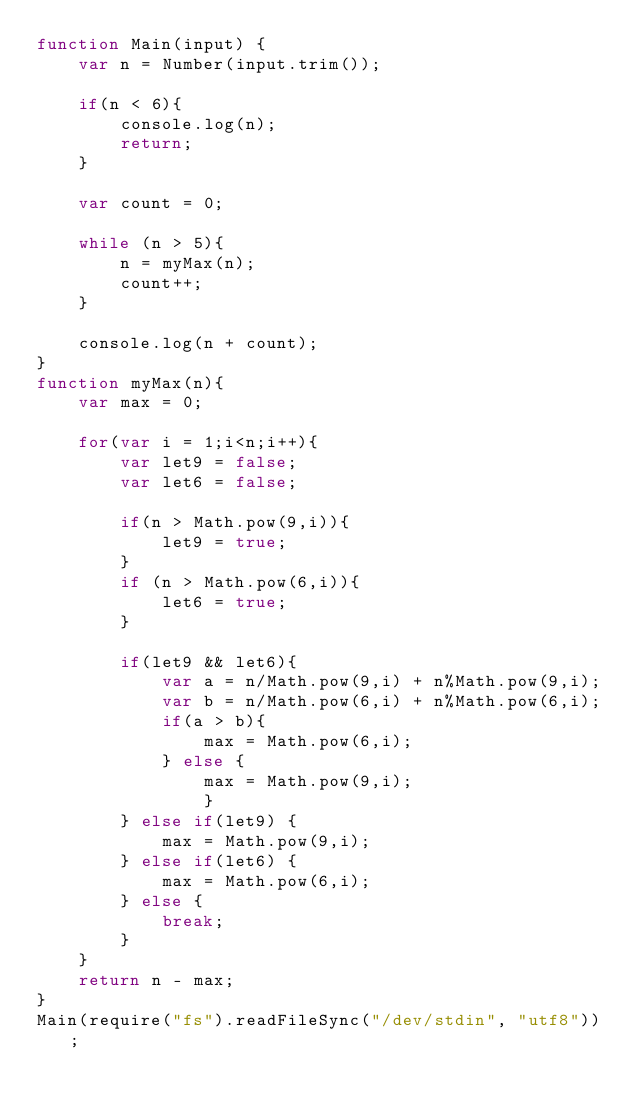<code> <loc_0><loc_0><loc_500><loc_500><_JavaScript_>function Main(input) {
	var n = Number(input.trim());
	
	if(n < 6){
		console.log(n);
		return;
	}
	
	var count = 0;
	
	while (n > 5){
		n = myMax(n);
		count++;
	}
	
	console.log(n + count);
}
function myMax(n){
	var max = 0;
	
	for(var i = 1;i<n;i++){
		var let9 = false;
		var let6 = false;
	
		if(n > Math.pow(9,i)){
			let9 = true;
		} 
		if (n > Math.pow(6,i)){
			let6 = true;
		}
		
		if(let9 && let6){
			var a = n/Math.pow(9,i) + n%Math.pow(9,i);
			var b = n/Math.pow(6,i) + n%Math.pow(6,i);
			if(a > b){
				max = Math.pow(6,i);
			} else {
				max = Math.pow(9,i);
				}
		} else if(let9) {
			max = Math.pow(9,i);
		} else if(let6) {
			max = Math.pow(6,i);
		} else {
			break;
		}
	}
	return n - max;
}
Main(require("fs").readFileSync("/dev/stdin", "utf8"));</code> 